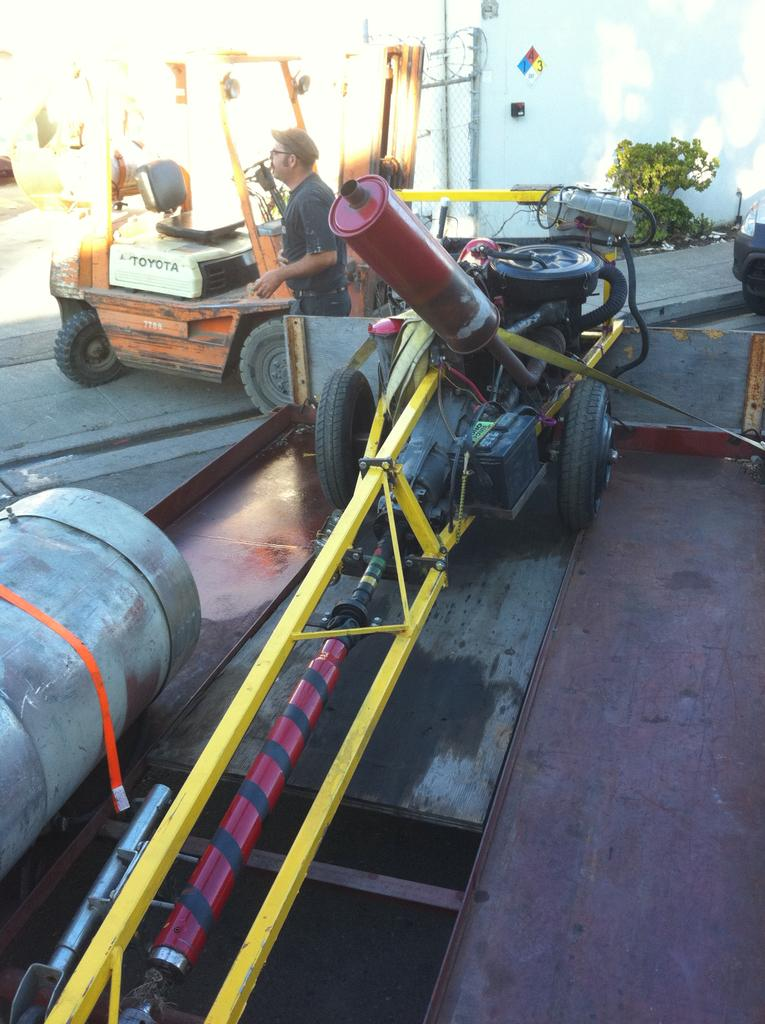What type of mechanical components can be seen in the image? In the image, there are wheels, an engine, rods, cables, and a mesh. What kind of vehicle is present in the image? There is a vehicle in the image. Can you describe the natural elements in the image? There are plants in the image. What is the background of the image composed of? The background of the image includes a wall. Who or what is present in the image along with the mechanical components and vehicle? There is a person in the image. What type of milk is being delivered by the goldfish in the mailbox in the image? There is no goldfish, milk, or mailbox present in the image. 